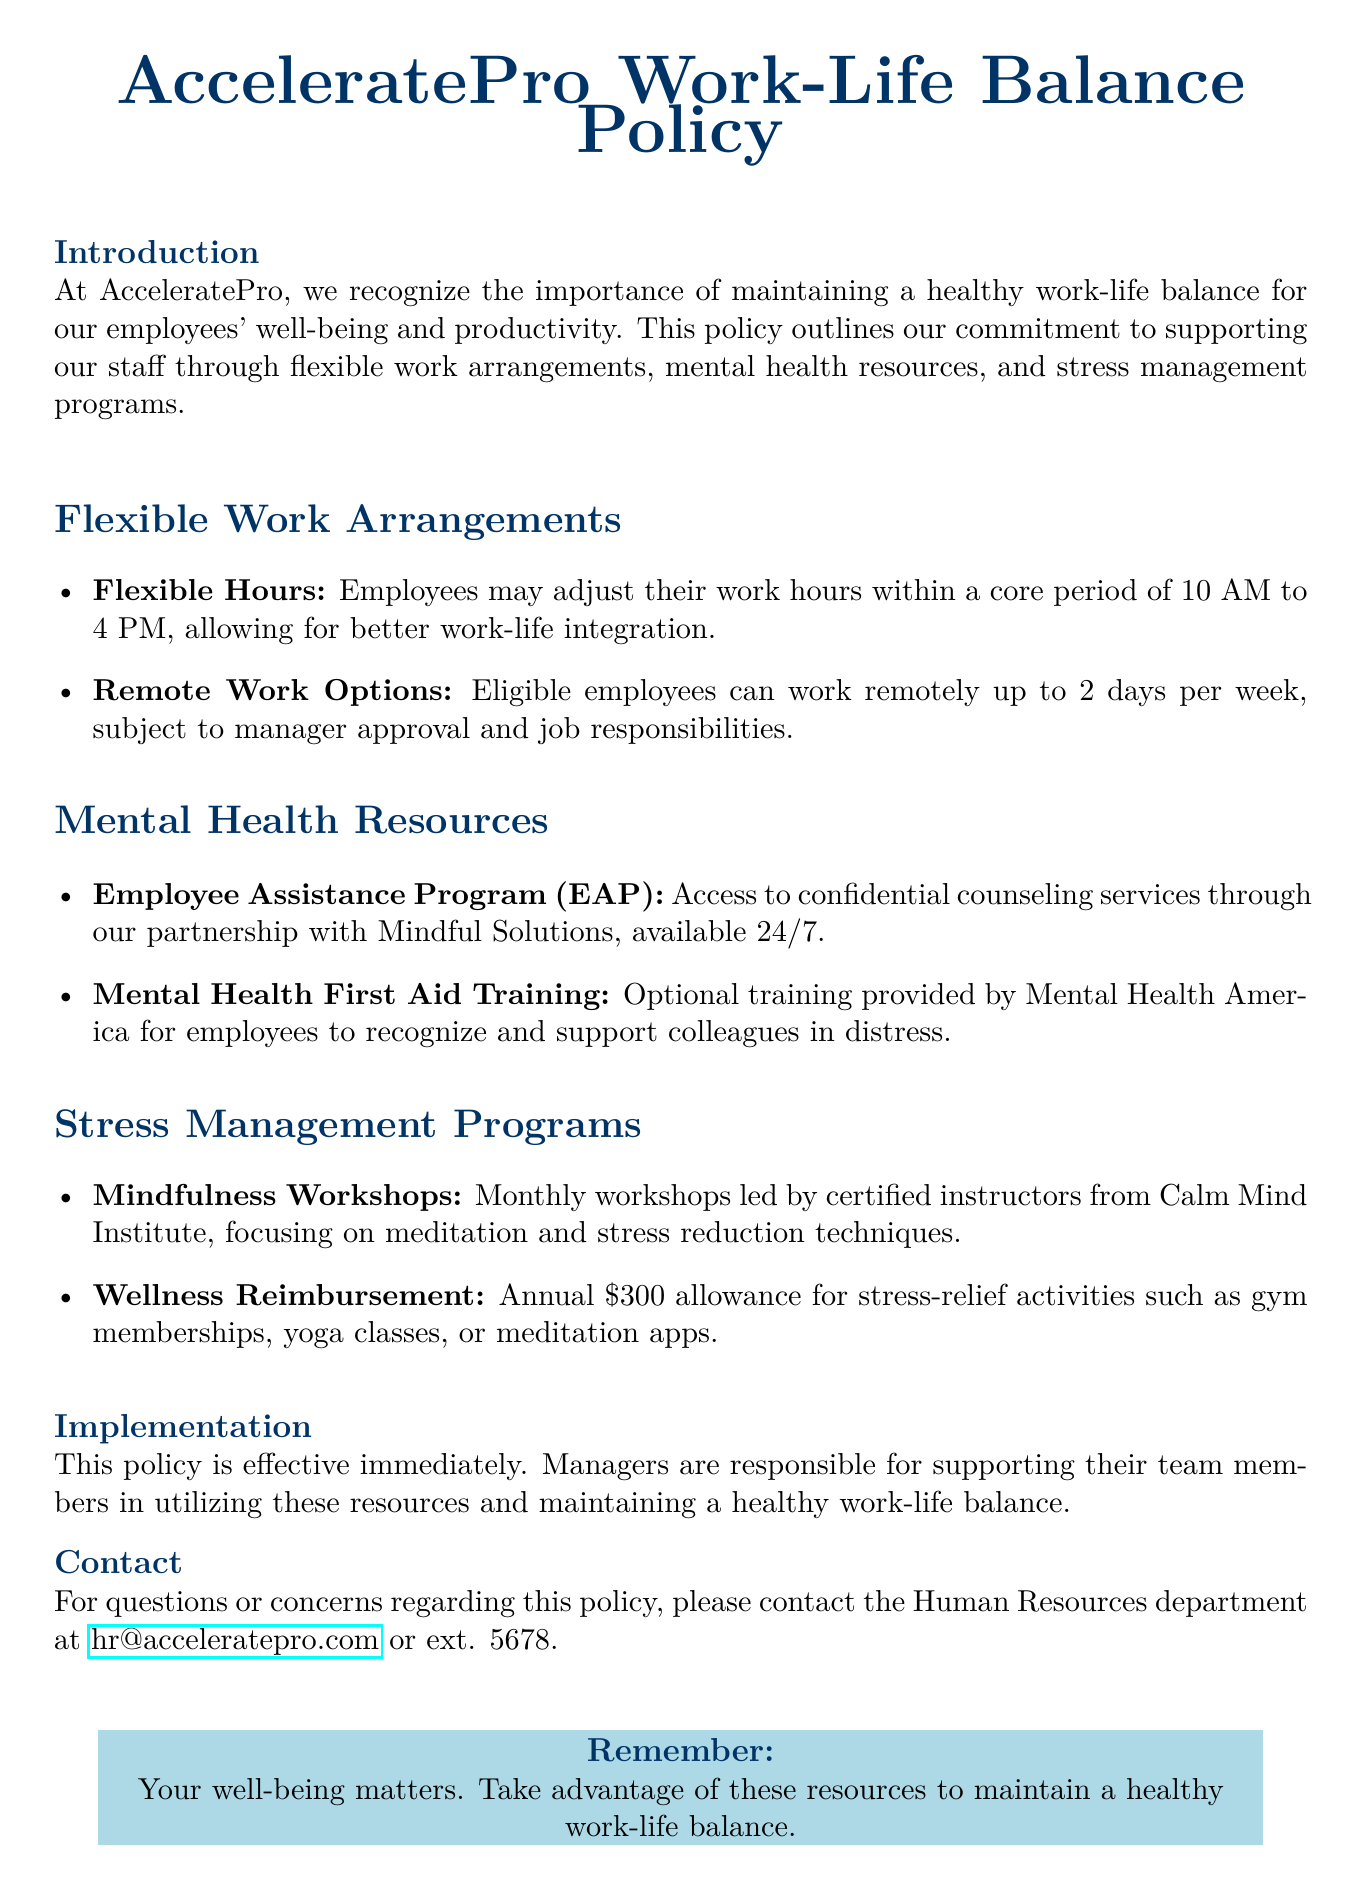What is the core period for flexible hours? The core period for flexible hours is specified in the document to allow for better work-life integration.
Answer: 10 AM to 4 PM How many remote work days are allowed per week? The policy specifies the maximum number of remote work days that a full-time employee can take in a week.
Answer: 2 days What is the name of the counseling service provided by the Employee Assistance Program? The document mentions a partnership with a specific organization that provides these counseling services.
Answer: Mindful Solutions What is the annual allowance for wellness reimbursement? The document states the specific amount provided for stress-relief activities each year.
Answer: $300 Who offers the Mental Health First Aid Training? The document identifies the organization that provides this optional training to employees.
Answer: Mental Health America What type of workshops are held monthly? The document describes the type of workshops designed to help reduce stress.
Answer: Mindfulness Workshops What is the purpose of the Employee Assistance Program? The document outlines the main service that the EAP provides to employees.
Answer: Confidential counseling services Who is responsible for supporting team members in using the resources? The policy specifies the role of a particular group or individual in relation to employee resources.
Answer: Managers What should employees do if they have questions about the policy? The document provides a clear course of action for inquiries regarding the policy.
Answer: Contact the Human Resources department 